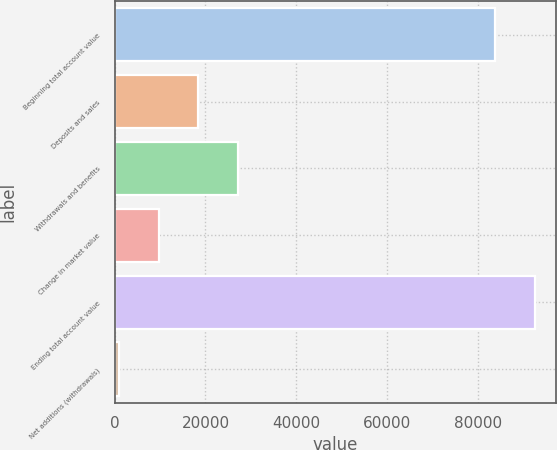Convert chart to OTSL. <chart><loc_0><loc_0><loc_500><loc_500><bar_chart><fcel>Beginning total account value<fcel>Deposits and sales<fcel>Withdrawals and benefits<fcel>Change in market value<fcel>Ending total account value<fcel>Net additions (withdrawals)<nl><fcel>83891<fcel>18406.6<fcel>27153.9<fcel>9659.3<fcel>92638.3<fcel>912<nl></chart> 